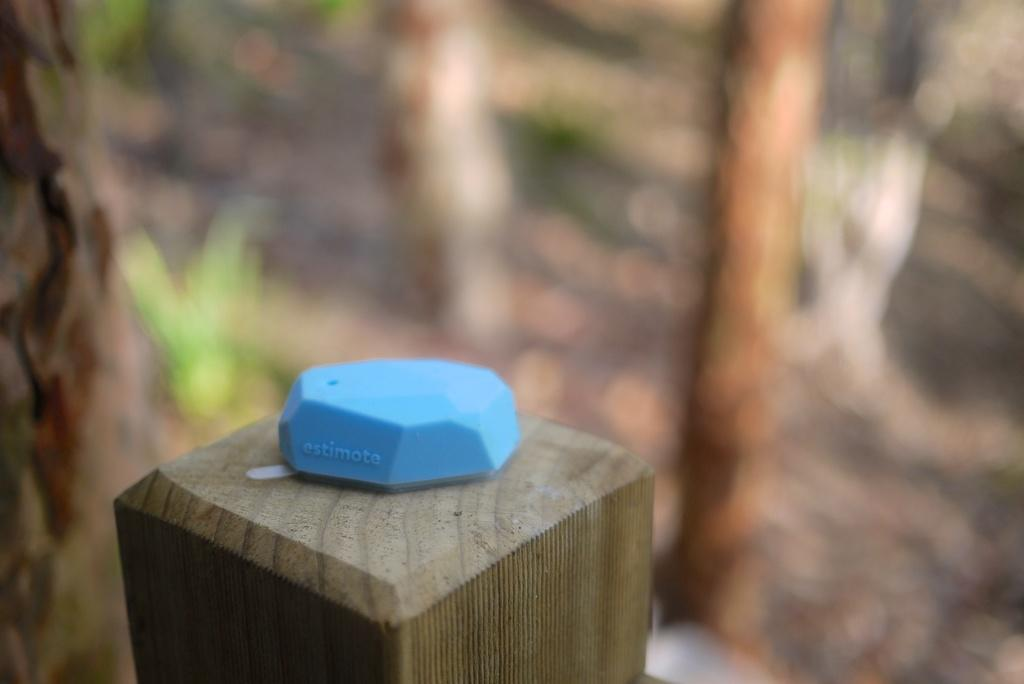What is the main object in the image? There is an object on wood in the image. Can you describe the background of the image? The background of the image is blurry. What type of throat medicine is visible in the image? There is no throat medicine present in the image. Is the image taken during winter, as indicated by the presence of snow? There is no indication of snow or winter in the image. 